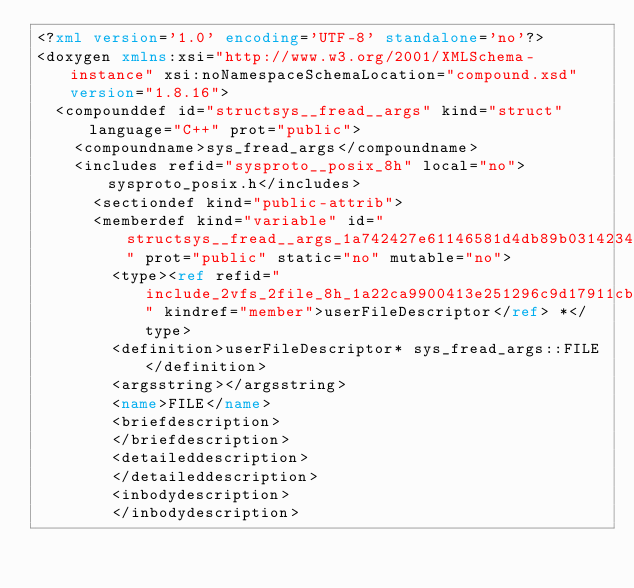Convert code to text. <code><loc_0><loc_0><loc_500><loc_500><_XML_><?xml version='1.0' encoding='UTF-8' standalone='no'?>
<doxygen xmlns:xsi="http://www.w3.org/2001/XMLSchema-instance" xsi:noNamespaceSchemaLocation="compound.xsd" version="1.8.16">
  <compounddef id="structsys__fread__args" kind="struct" language="C++" prot="public">
    <compoundname>sys_fread_args</compoundname>
    <includes refid="sysproto__posix_8h" local="no">sysproto_posix.h</includes>
      <sectiondef kind="public-attrib">
      <memberdef kind="variable" id="structsys__fread__args_1a742427e61146581d4db89b0314234a47" prot="public" static="no" mutable="no">
        <type><ref refid="include_2vfs_2file_8h_1a22ca9900413e251296c9d17911cb24f5" kindref="member">userFileDescriptor</ref> *</type>
        <definition>userFileDescriptor* sys_fread_args::FILE</definition>
        <argsstring></argsstring>
        <name>FILE</name>
        <briefdescription>
        </briefdescription>
        <detaileddescription>
        </detaileddescription>
        <inbodydescription>
        </inbodydescription></code> 